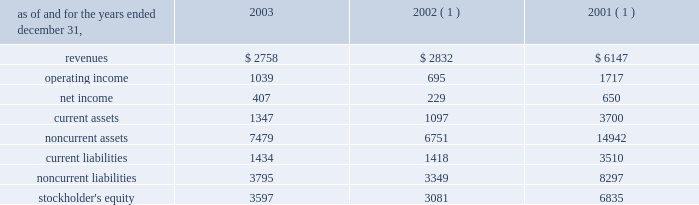In the fourth quarter of 2002 , aes lost voting control of one of the holding companies in the cemig ownership structure .
This holding company indirectly owns the shares related to the cemig investment and indirectly holds the project financing debt related to cemig .
As a result of the loss of voting control , aes stopped consolidating this holding company at december 31 , 2002 .
Other .
During the fourth quarter of 2003 , the company sold its 25% ( 25 % ) ownership interest in medway power limited ( 2018 2018mpl 2019 2019 ) , a 688 mw natural gas-fired combined cycle facility located in the united kingdom , and aes medway operations limited ( 2018 2018aesmo 2019 2019 ) , the operating company for the facility , in an aggregate transaction valued at approximately a347 million ( $ 78 million ) .
The sale resulted in a gain of $ 23 million which was recorded in continuing operations .
Mpl and aesmo were previously reported in the contract generation segment .
In the second quarter of 2002 , the company sold its investment in empresa de infovias s.a .
( 2018 2018infovias 2019 2019 ) , a telecommunications company in brazil , for proceeds of $ 31 million to cemig , an affiliated company .
The loss recorded on the sale was approximately $ 14 million and is recorded as a loss on sale of assets and asset impairment expenses in the accompanying consolidated statements of operations .
In the second quarter of 2002 , the company recorded an impairment charge of approximately $ 40 million , after income taxes , on an equity method investment in a telecommunications company in latin america held by edc .
The impairment charge resulted from sustained poor operating performance coupled with recent funding problems at the invested company .
During 2001 , the company lost operational control of central electricity supply corporation ( 2018 2018cesco 2019 2019 ) , a distribution company located in the state of orissa , india .
The state of orissa appointed an administrator to take operational control of cesco .
Cesco is accounted for as a cost method investment .
Aes 2019s investment in cesco is negative .
In august 2000 , a subsidiary of the company acquired a 49% ( 49 % ) interest in songas for approximately $ 40 million .
The company acquired an additional 16.79% ( 16.79 % ) of songas for approximately $ 12.5 million , and the company began consolidating this entity in 2002 .
Songas owns the songo songo gas-to-electricity project in tanzania .
In december 2002 , the company signed a sales purchase agreement to sell 100% ( 100 % ) of our ownership interest in songas .
The sale of songas closed in april 2003 ( see note 4 for further discussion of the transaction ) .
The tables present summarized comparative financial information ( in millions ) of the entities in which the company has the ability to exercise significant influence but does not control and that are accounted for using the equity method. .
( 1 ) includes information pertaining to eletropaulo and light prior to february 2002 .
In 2002 and 2001 , the results of operations and the financial position of cemig were negatively impacted by the devaluation of the brazilian real and the impairment charge recorded in 2002 .
The brazilian real devalued 32% ( 32 % ) and 19% ( 19 % ) for the years ended december 31 , 2002 and 2001 , respectively. .
What is the implied total value of medway power limited , in us$ ? 
Computations: ((78 / 25%) * 1000000)
Answer: 312000000.0. 